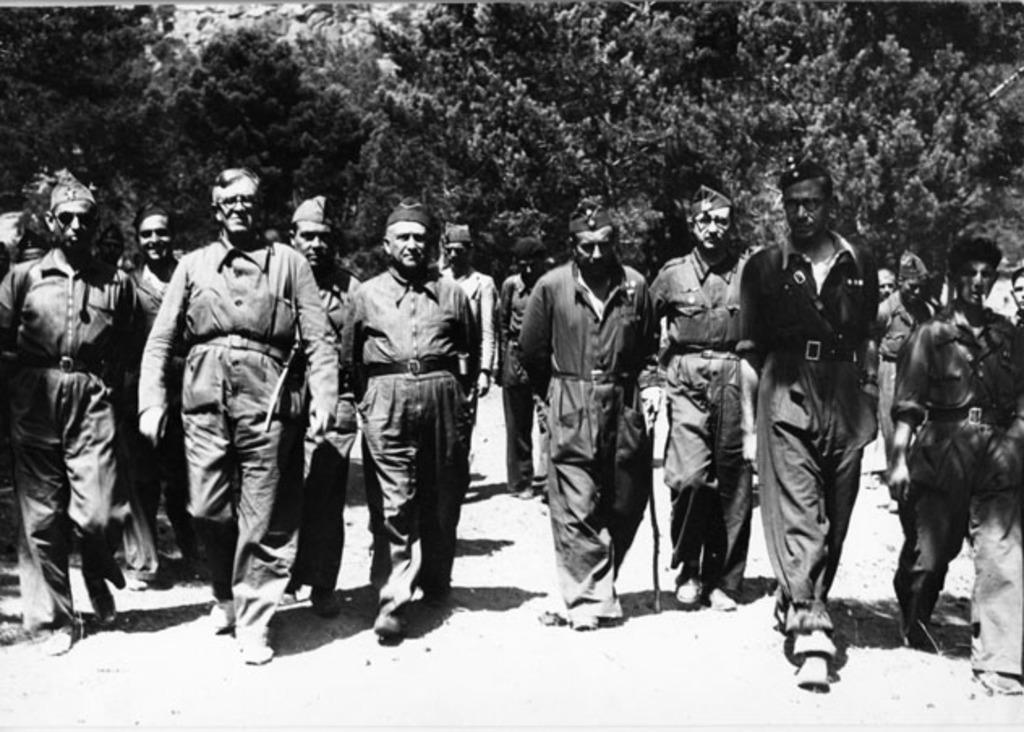What is happening in the image? There is a group of people in the image, and they are walking. What are the people wearing in the image? The people are wearing coats, caps, and shoes. What can be seen in the background of the image? There are trees in the background of the image. What is the color scheme of the image? The image is in black and white color. What type of wire is being used by the people in the image? There is no wire present in the image; the people are walking and wearing coats, caps, and shoes. What historical event is depicted in the image? The image does not depict any specific historical event; it simply shows a group of people walking while wearing coats, caps, and shoes. How many spiders can be seen on the people's shoes in the image? There are no spiders visible on the people's shoes in the image. 